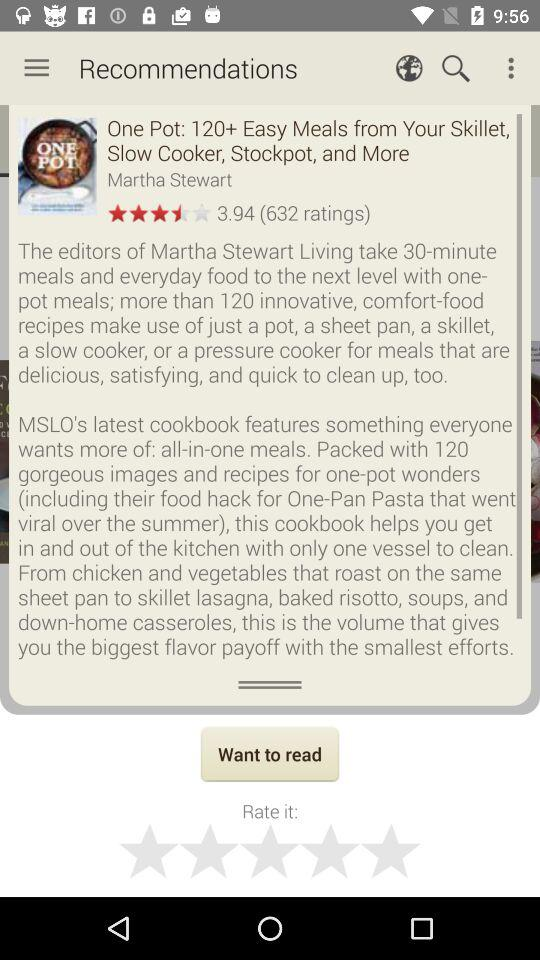What is the rating of "One Pot"? The rating is 3.94. 